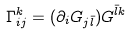<formula> <loc_0><loc_0><loc_500><loc_500>\Gamma _ { i j } ^ { k } = ( \partial _ { i } G _ { j { \bar { l } } } ) G ^ { { \bar { l } } k } \,</formula> 